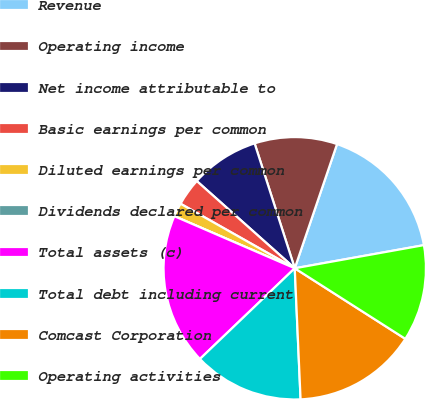<chart> <loc_0><loc_0><loc_500><loc_500><pie_chart><fcel>Revenue<fcel>Operating income<fcel>Net income attributable to<fcel>Basic earnings per common<fcel>Diluted earnings per common<fcel>Dividends declared per common<fcel>Total assets (c)<fcel>Total debt including current<fcel>Comcast Corporation<fcel>Operating activities<nl><fcel>16.95%<fcel>10.17%<fcel>8.47%<fcel>3.39%<fcel>1.69%<fcel>0.0%<fcel>18.64%<fcel>13.56%<fcel>15.25%<fcel>11.86%<nl></chart> 